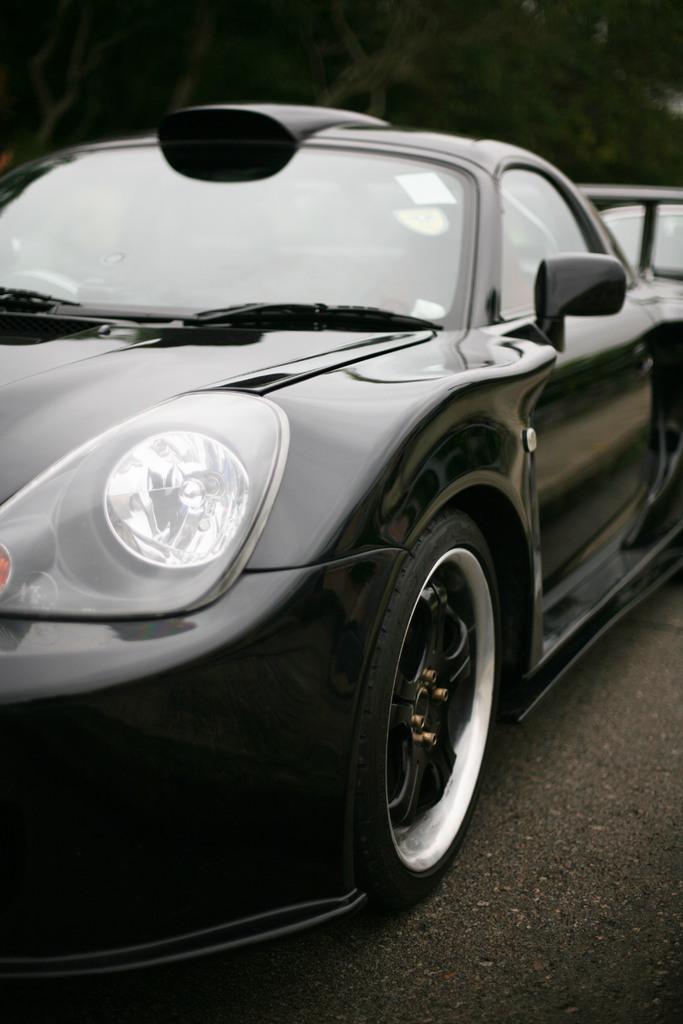Describe this image in one or two sentences. In this image there is a black colored car, there is road towards the bottom of the image, the background of the image is blurred. 